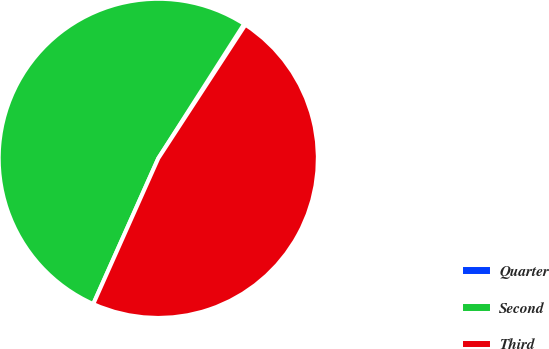<chart> <loc_0><loc_0><loc_500><loc_500><pie_chart><fcel>Quarter<fcel>Second<fcel>Third<nl><fcel>0.15%<fcel>52.36%<fcel>47.48%<nl></chart> 